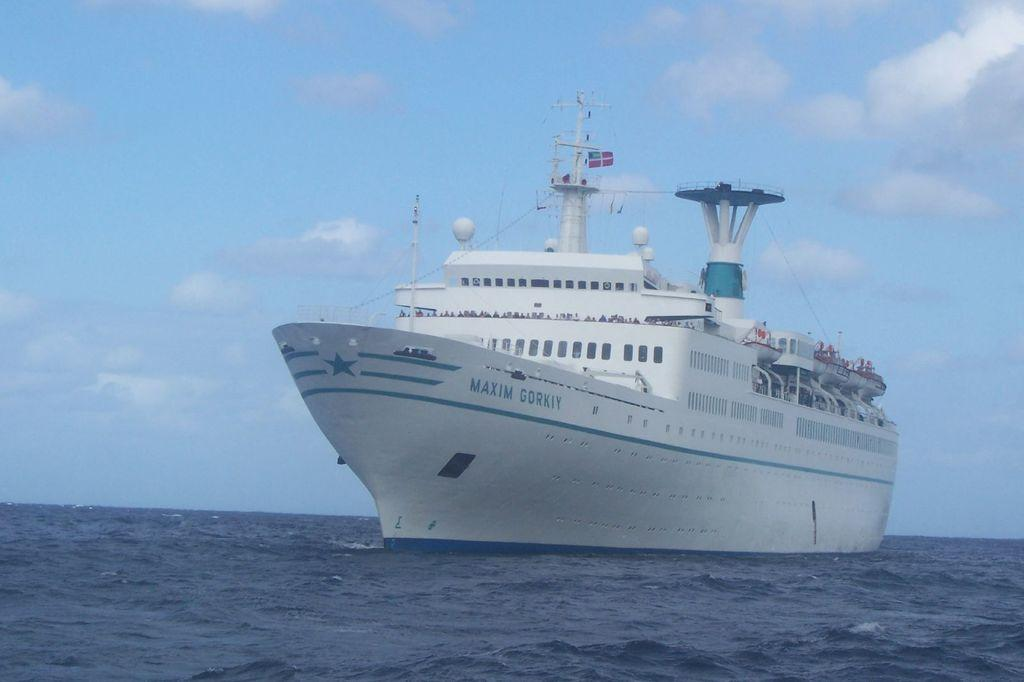What is the main subject of the image? The main subject of the image is a ship. Where is the ship located in the image? The ship is on the water in the image. What is visible in the background of the image? The sky is visible in the background of the image. Can you describe the sky in the background of the image? The sky in the background of the image has clouds. What type of grain can be seen growing near the ship in the image? There is no grain visible in the image; it features a ship on the water with a cloudy sky in the background. What season is it in the image, considering the presence of leaves? There are no leaves present in the image, so it is not possible to determine the season. 